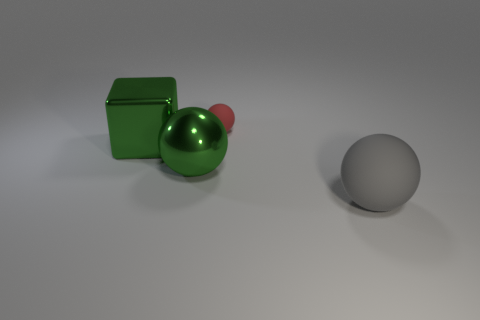The tiny thing that is made of the same material as the large gray sphere is what shape?
Provide a succinct answer. Sphere. Is the shape of the rubber object that is in front of the small sphere the same as  the small red thing?
Your answer should be very brief. Yes. What shape is the matte object that is in front of the big shiny cube?
Provide a succinct answer. Sphere. The large shiny thing that is the same color as the metal sphere is what shape?
Provide a succinct answer. Cube. How many green objects are the same size as the green block?
Ensure brevity in your answer.  1. What color is the shiny block?
Provide a succinct answer. Green. Do the big block and the metal thing on the right side of the big green metal block have the same color?
Make the answer very short. Yes. The other ball that is made of the same material as the big gray sphere is what size?
Your answer should be compact. Small. Is there a shiny block that has the same color as the metallic ball?
Provide a succinct answer. Yes. How many objects are large metal objects in front of the block or gray balls?
Keep it short and to the point. 2. 